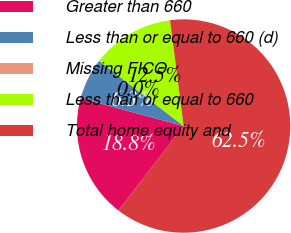Convert chart to OTSL. <chart><loc_0><loc_0><loc_500><loc_500><pie_chart><fcel>Greater than 660<fcel>Less than or equal to 660 (d)<fcel>Missing FICO<fcel>Less than or equal to 660<fcel>Total home equity and<nl><fcel>18.75%<fcel>6.25%<fcel>0.0%<fcel>12.5%<fcel>62.49%<nl></chart> 